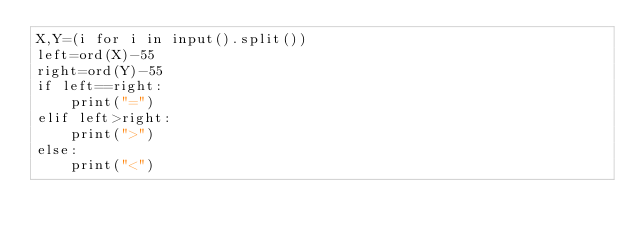<code> <loc_0><loc_0><loc_500><loc_500><_Python_>X,Y=(i for i in input().split())
left=ord(X)-55
right=ord(Y)-55
if left==right:
    print("=")
elif left>right:
    print(">")
else:
    print("<")</code> 